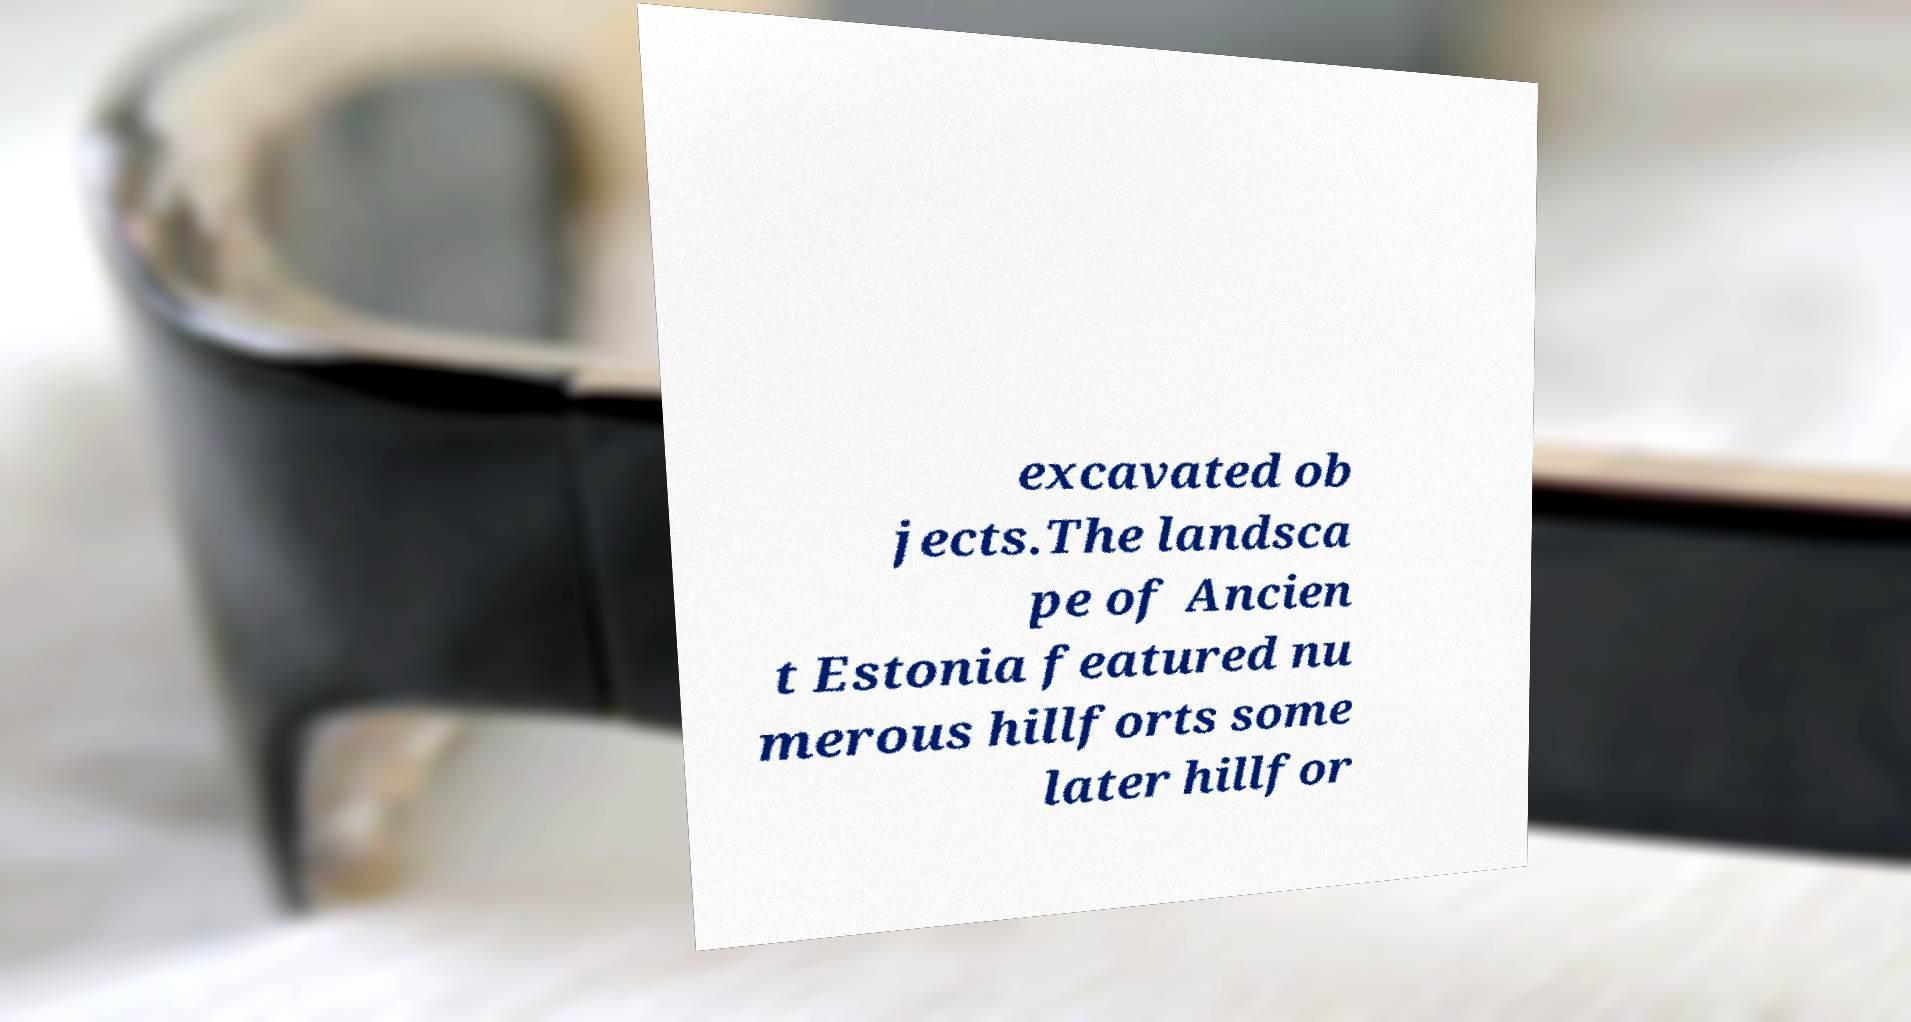There's text embedded in this image that I need extracted. Can you transcribe it verbatim? excavated ob jects.The landsca pe of Ancien t Estonia featured nu merous hillforts some later hillfor 